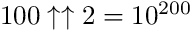<formula> <loc_0><loc_0><loc_500><loc_500>1 0 0 \uparrow \uparrow 2 = 1 0 ^ { 2 0 0 }</formula> 